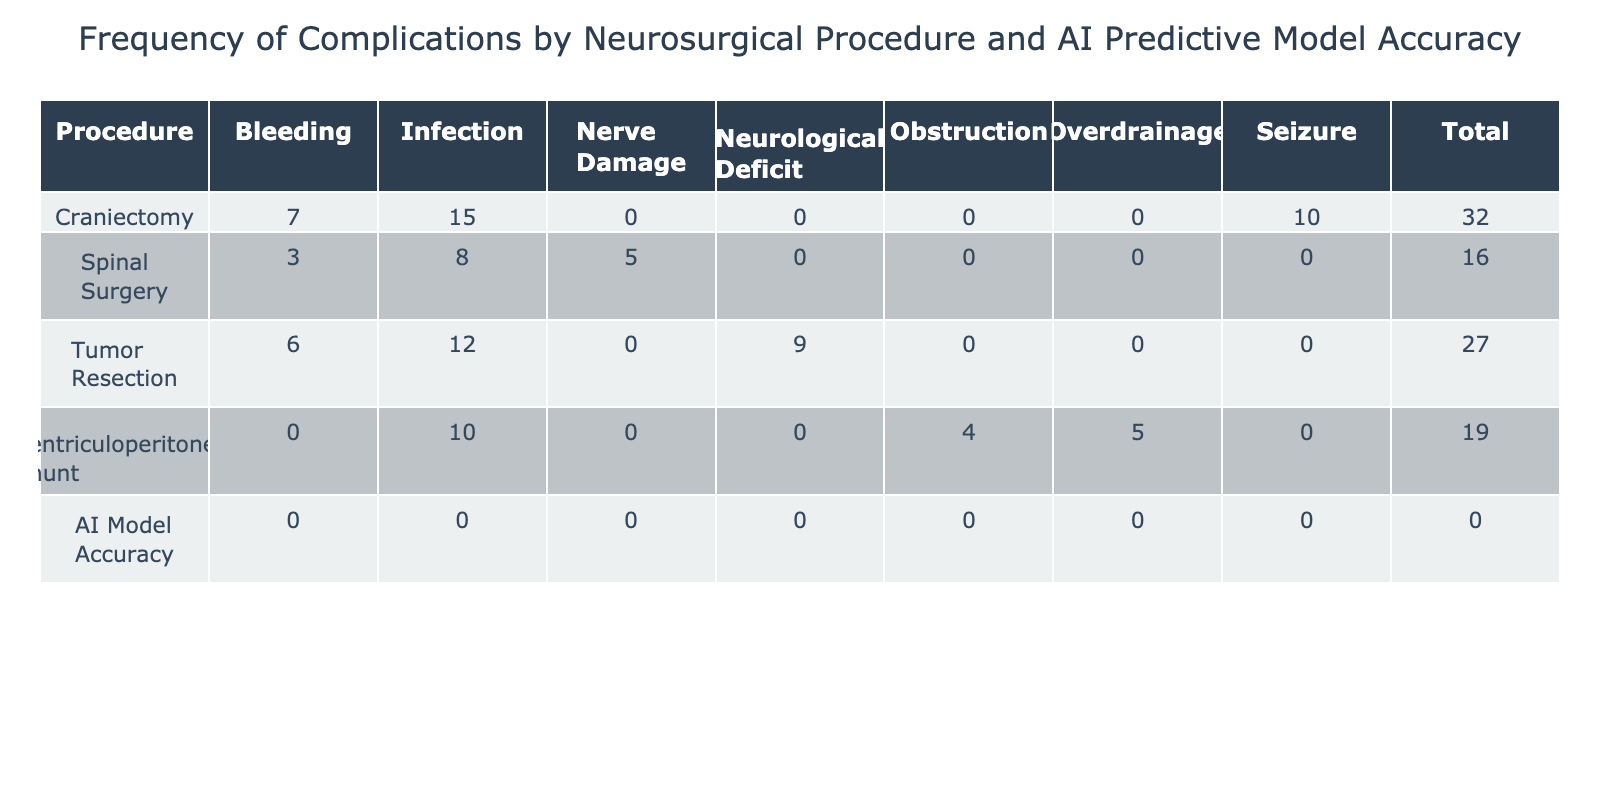What is the frequency of bleeding complications for Tumor Resection? The table shows that for the Tumor Resection procedure, the frequency of bleeding complications is recorded as 6.
Answer: 6 What is the total frequency of complications for Craniectomy? To find the total frequency of complications for Craniectomy, we sum up the frequencies of Infection (15), Seizure (10), and Bleeding (7). Thus, 15 + 10 + 7 = 32.
Answer: 32 Is the predictive model accuracy for Spinal Surgery greater than 0.80? The average AI predictive model accuracy for Spinal Surgery is calculated as the average of the accuracies for Nerve Damage (0.88), Infection (0.75), and Bleeding (0.92). The calculation results in (0.88 + 0.75 + 0.92) / 3 = 0.85, which is greater than 0.80.
Answer: Yes What is the complication type with the highest frequency in the table? By examining the frequency data, we see the highest frequency is for the Infection complication in Craniectomy with a frequency of 15.
Answer: Infection What is the average AI predictive model accuracy across all procedures? To find the average AI predictive model accuracy, we sum the accuracies for all procedures and divide by the number of procedures. The values are (0.85 + 0.80 + 0.90 + 0.88 + 0.75 + 0.92 + 0.87 + 0.83 + 0.91 + 0.89 + 0.81 + 0.86) which equals 10.46, and dividing by 12 yields an average of approximately 0.87.
Answer: 0.87 Is there a recorded complication for Ventriculoperitoneal Shunt procedures? The table shows several complications for Ventriculoperitoneal Shunt, namely Obstruction (4), Infection (10), and Overdrainage (5), indicating that there are indeed recorded complications.
Answer: Yes How many procedures have a complication with a frequency of 5 or less? By examining the individual frequencies, we can see that the complications for Spinal Surgery (Nerve Damage 5), Ventriculoperitoneal Shunt (Obstruction 4), and others also reach frequencies of 5 or less. Counting these, we find that there are 3 procedures corresponding to this condition.
Answer: 3 Which procedure has the lowest frequency of complications overall? To determine the procedure with the lowest overall frequency of complications, we can review the totals from the table. The procedure with the lowest total is Spinal Surgery, with a total frequency of 16 (5 + 8 + 3).
Answer: Spinal Surgery 